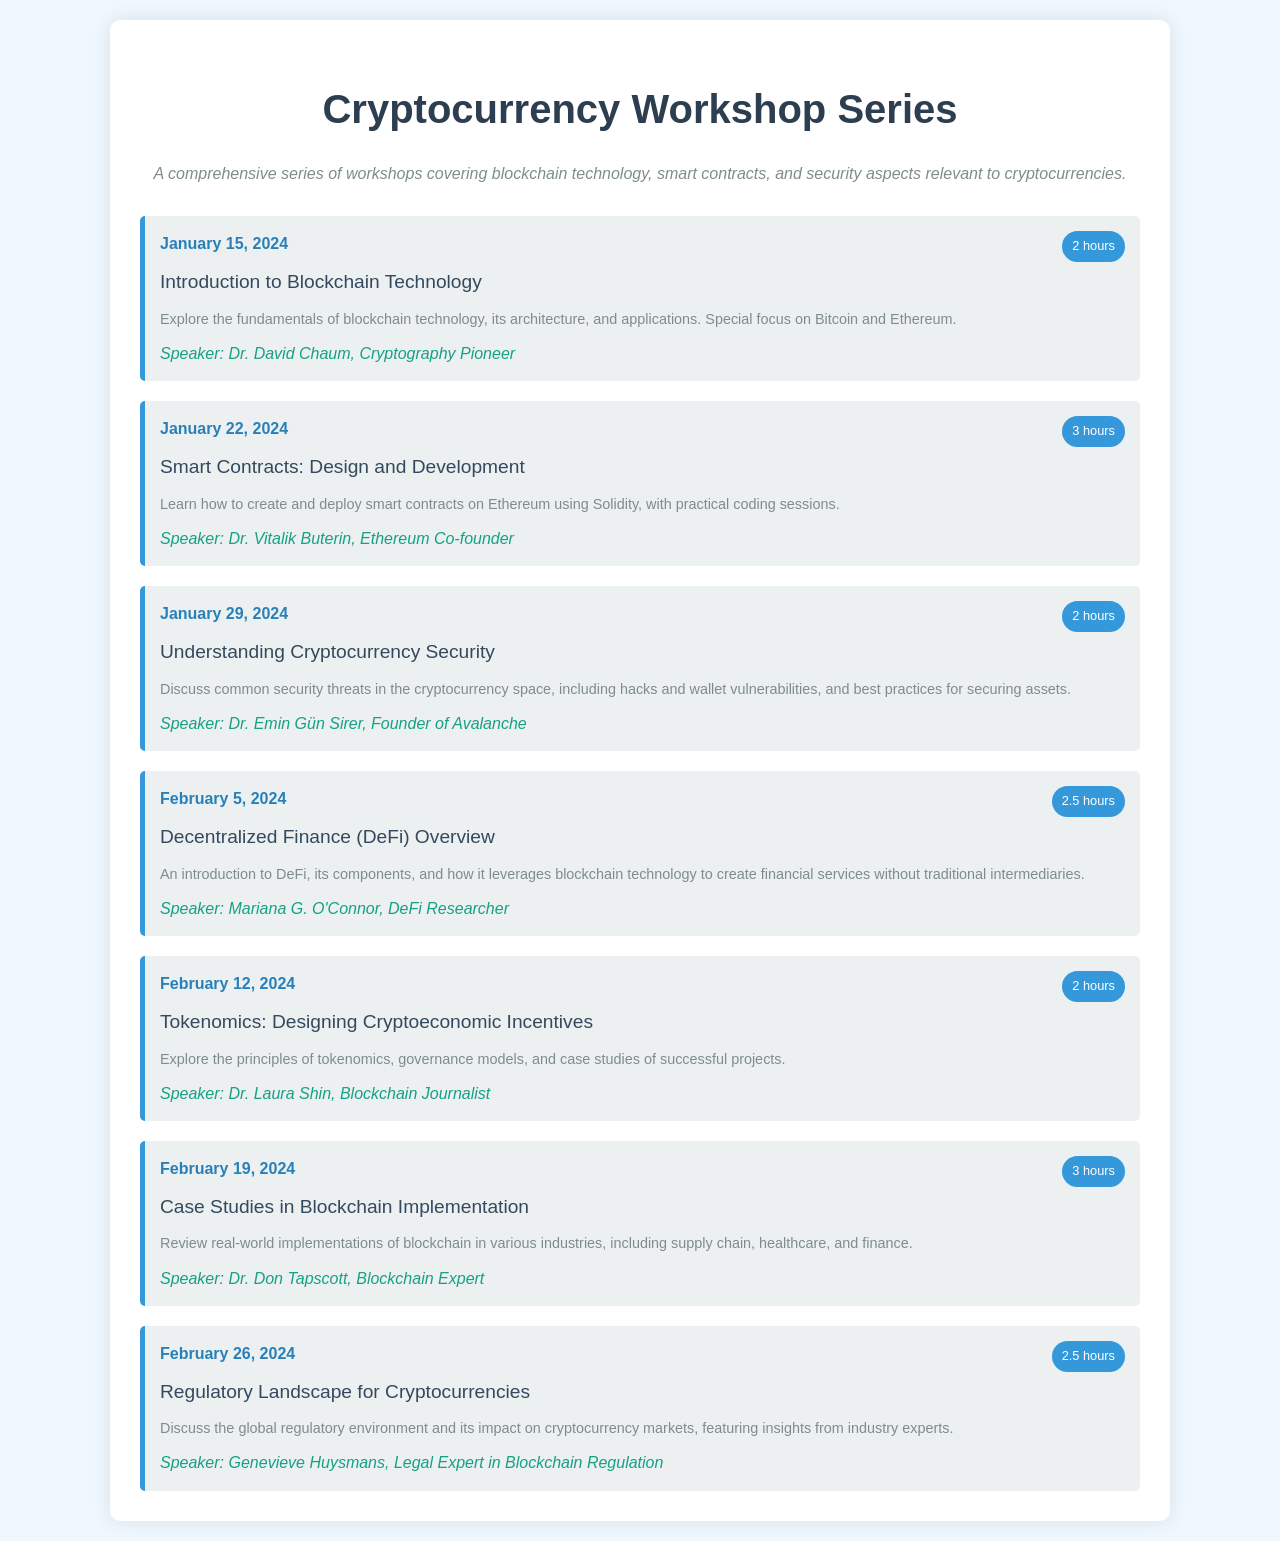What is the date of the first workshop? The first workshop is on January 15, 2024, as stated in the schedule.
Answer: January 15, 2024 Who is the speaker for the workshop on Smart Contracts? The speaker for the Smart Contracts workshop is Dr. Vitalik Buterin, mentioned in the event details.
Answer: Dr. Vitalik Buterin How long is the workshop on Cryptocurrency Security? The duration of the Cryptocurrency Security workshop is mentioned as 2 hours.
Answer: 2 hours What topic is covered on February 5, 2024? The topic for that date is “Decentralized Finance (DeFi) Overview,” as per the event schedule.
Answer: Decentralized Finance (DeFi) Overview Which workshop has a duration of 3 hours? Two workshops in the schedule have a duration of 3 hours: “Smart Contracts” and “Case Studies in Blockchain Implementation.”
Answer: Smart Contracts, Case Studies in Blockchain Implementation What is the main focus of the Tokenomics workshop? The main focus of the Tokenomics workshop is on designing cryptoeconomic incentives, as stated in the description.
Answer: Designing Cryptoeconomic Incentives How many total workshops are scheduled? The total number of workshops is counted from the event listings, which is seven.
Answer: Seven Which speaker is associated with the regulatory landscape topic? The workshop on the regulatory landscape is led by Genevieve Huysmans, as mentioned in the event details.
Answer: Genevieve Huysmans 